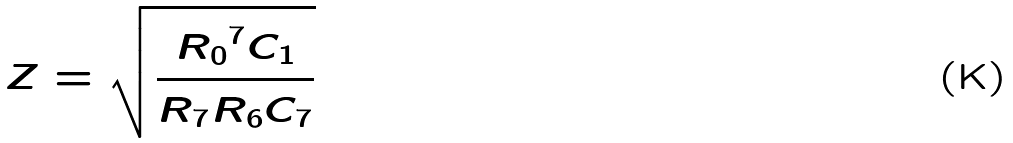Convert formula to latex. <formula><loc_0><loc_0><loc_500><loc_500>Z = \sqrt { \frac { { R _ { 0 } } ^ { 7 } C _ { 1 } } { R _ { 7 } R _ { 6 } C _ { 7 } } }</formula> 